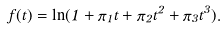<formula> <loc_0><loc_0><loc_500><loc_500>f ( t ) = \ln ( 1 + \pi _ { 1 } t + \pi _ { 2 } t ^ { 2 } + \pi _ { 3 } t ^ { 3 } ) .</formula> 